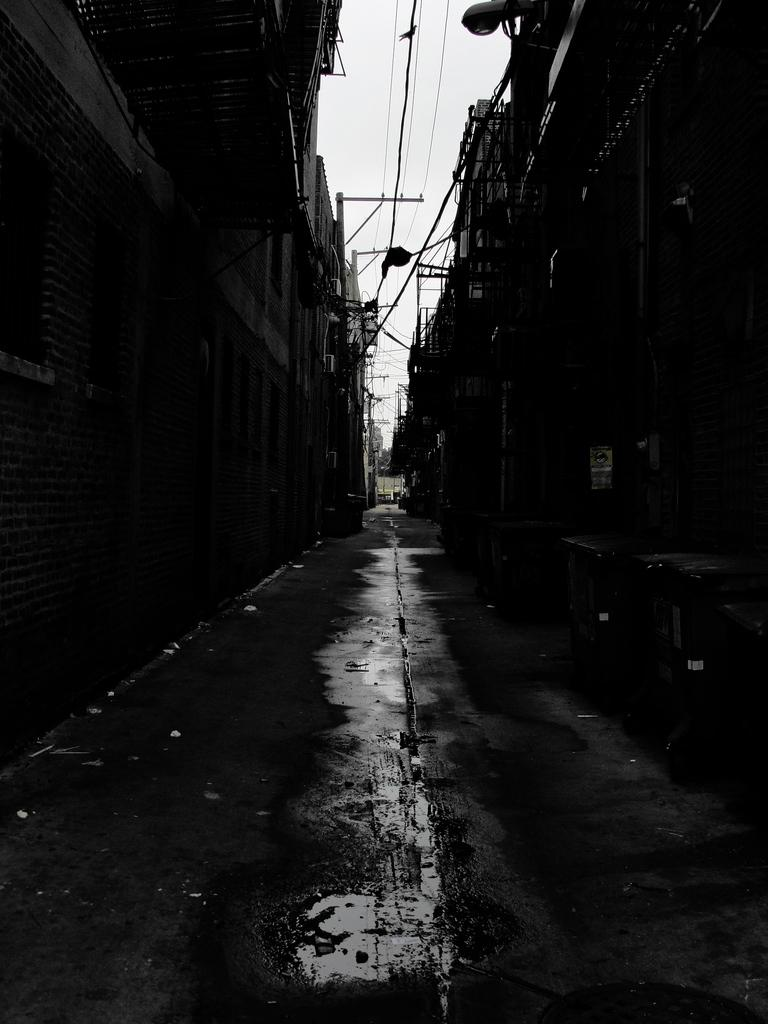What type of structures can be seen in the image? There are buildings in the image. What is the purpose of the footpath in the image? The footpath in the image is likely for pedestrians to walk on. What is the pole in the image used for? The pole in the image might be used to support electric wires or street signs. What can be seen in the sky in the image? The sky is white in the image. What is the rest of the group's belief about the agreement in the image? There is no group, belief, or agreement present in the image; it only features buildings, a footpath, a pole, electric wires, and a white sky. 